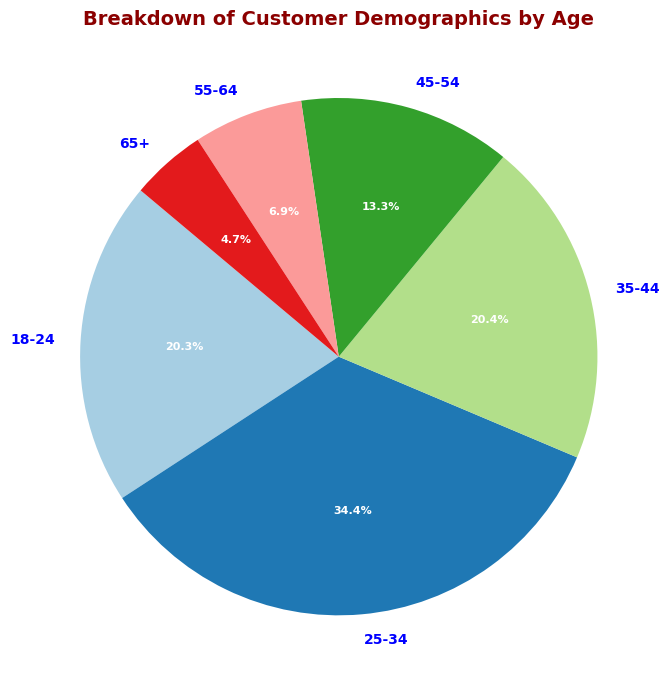What age group has the highest percentage of customers? By looking at the pie chart, the slice for the 25-34 age group is the largest, indicating it has the highest percentage.
Answer: 25-34 Which age group has the smallest percentage of customers? Observing the pie chart, the slice for the age group 65+ is the smallest.
Answer: 65+ What is the total percentage of customers aged between 35-54? Add the percentages of the 35-44 and 45-54 age groups: 15.8% (35-44) + 10.4% (45-54) = 26.2%.
Answer: 26.2% Is the percentage of customers aged 18-24 more than or less than those aged 55+? Compare the percentages: 18-24 (12.5%) is more than 55+(10.8% = 5.2% + 3.6% + 1.0% for 55-64 and 65+ respectively).
Answer: More Which segment of the pie chart is colored the most vibrant (brightest)? Typically, in pie charts, categories of demographic segmentation like younger age groups often receive brighter colors for distinction; thus, the slice representing the age group 25-34 is often the brightest amongst them as it attracts the viewer’s eye being one of the major categories.
Answer: 25-34 What is the percentage difference between the 25-34 and 65+ age groups? Subtract the percentage of the 65+ age group from the 25-34 age group: 22.3% - 3.6% = 18.7%.
Answer: 18.7% What age group represents approximately one-quarter of the customer base? The pie chart slice closest to 25% is for the 25-34 age group, which is 22.3%.
Answer: 25-34 